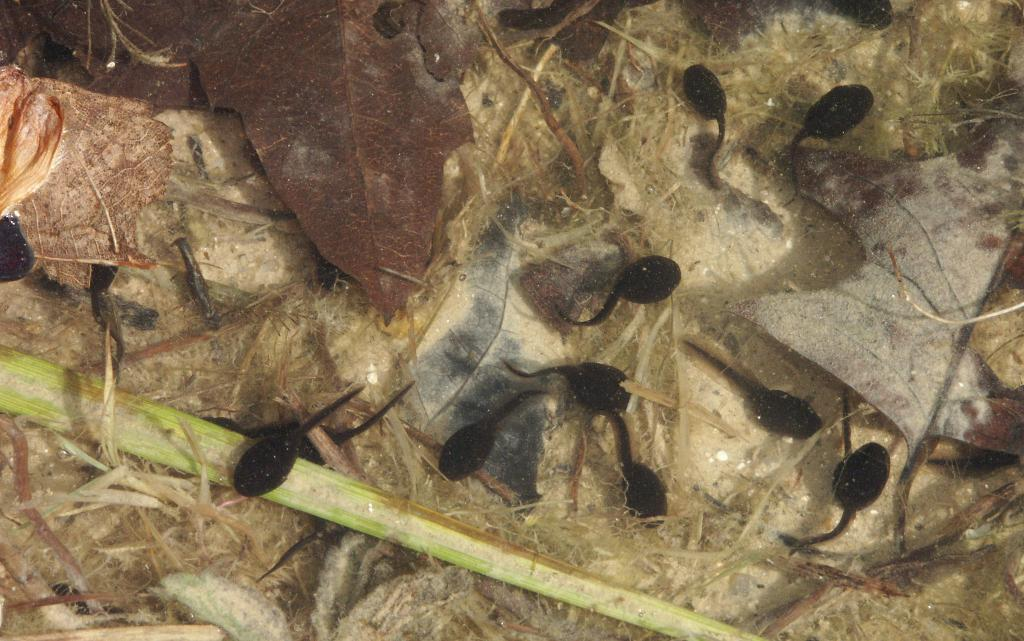What type of creatures are present in the image? There is a group of insects in the image. What can be seen on the floor in the image? There are dried leaves on the floor in the image. How many women are standing near the mailbox in the image? There is no mailbox or women present in the image; it features a group of insects and dried leaves on the floor. 